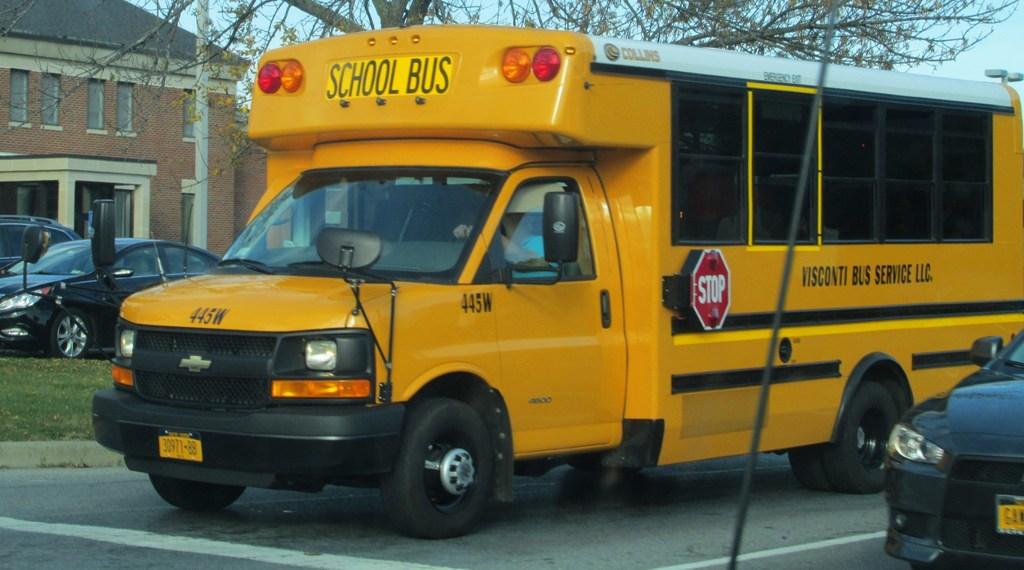What is the bus' id number?
Provide a short and direct response. 445w. What does the red sign on the bus instruct drivers to do?
Provide a succinct answer. Stop. 